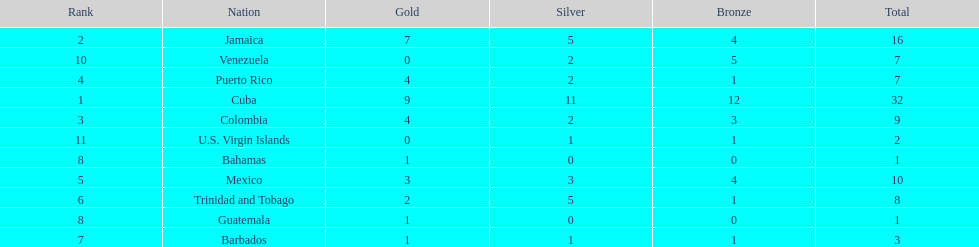What is the total number of gold medals awarded between these 11 countries? 32. 